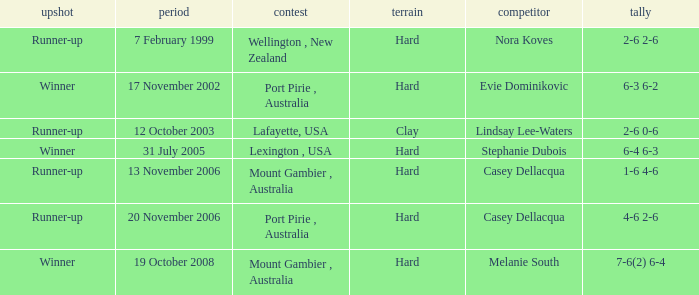Can you parse all the data within this table? {'header': ['upshot', 'period', 'contest', 'terrain', 'competitor', 'tally'], 'rows': [['Runner-up', '7 February 1999', 'Wellington , New Zealand', 'Hard', 'Nora Koves', '2-6 2-6'], ['Winner', '17 November 2002', 'Port Pirie , Australia', 'Hard', 'Evie Dominikovic', '6-3 6-2'], ['Runner-up', '12 October 2003', 'Lafayette, USA', 'Clay', 'Lindsay Lee-Waters', '2-6 0-6'], ['Winner', '31 July 2005', 'Lexington , USA', 'Hard', 'Stephanie Dubois', '6-4 6-3'], ['Runner-up', '13 November 2006', 'Mount Gambier , Australia', 'Hard', 'Casey Dellacqua', '1-6 4-6'], ['Runner-up', '20 November 2006', 'Port Pirie , Australia', 'Hard', 'Casey Dellacqua', '4-6 2-6'], ['Winner', '19 October 2008', 'Mount Gambier , Australia', 'Hard', 'Melanie South', '7-6(2) 6-4']]} Which Score has an Opponent of melanie south? 7-6(2) 6-4. 